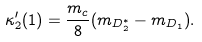<formula> <loc_0><loc_0><loc_500><loc_500>\kappa ^ { \prime } _ { 2 } ( 1 ) = \frac { m _ { c } } { 8 } ( m _ { D ^ { * } _ { 2 } } - m _ { D _ { 1 } } ) .</formula> 